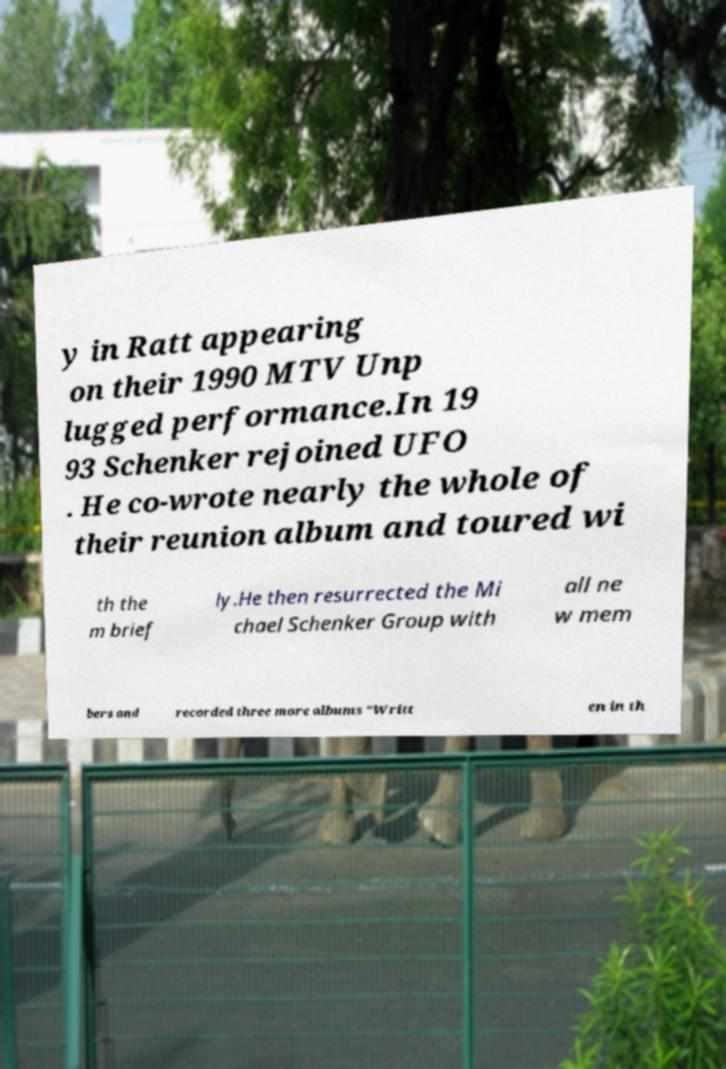Please identify and transcribe the text found in this image. y in Ratt appearing on their 1990 MTV Unp lugged performance.In 19 93 Schenker rejoined UFO . He co-wrote nearly the whole of their reunion album and toured wi th the m brief ly.He then resurrected the Mi chael Schenker Group with all ne w mem bers and recorded three more albums "Writt en in th 